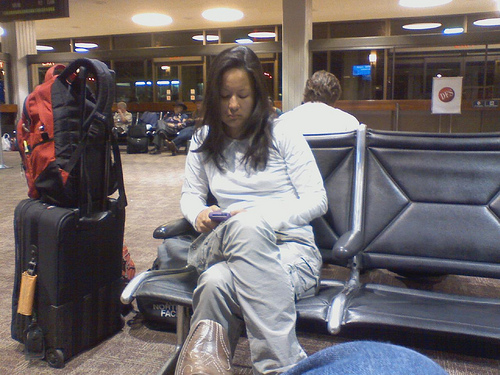Please identify all text content in this image. FAC 